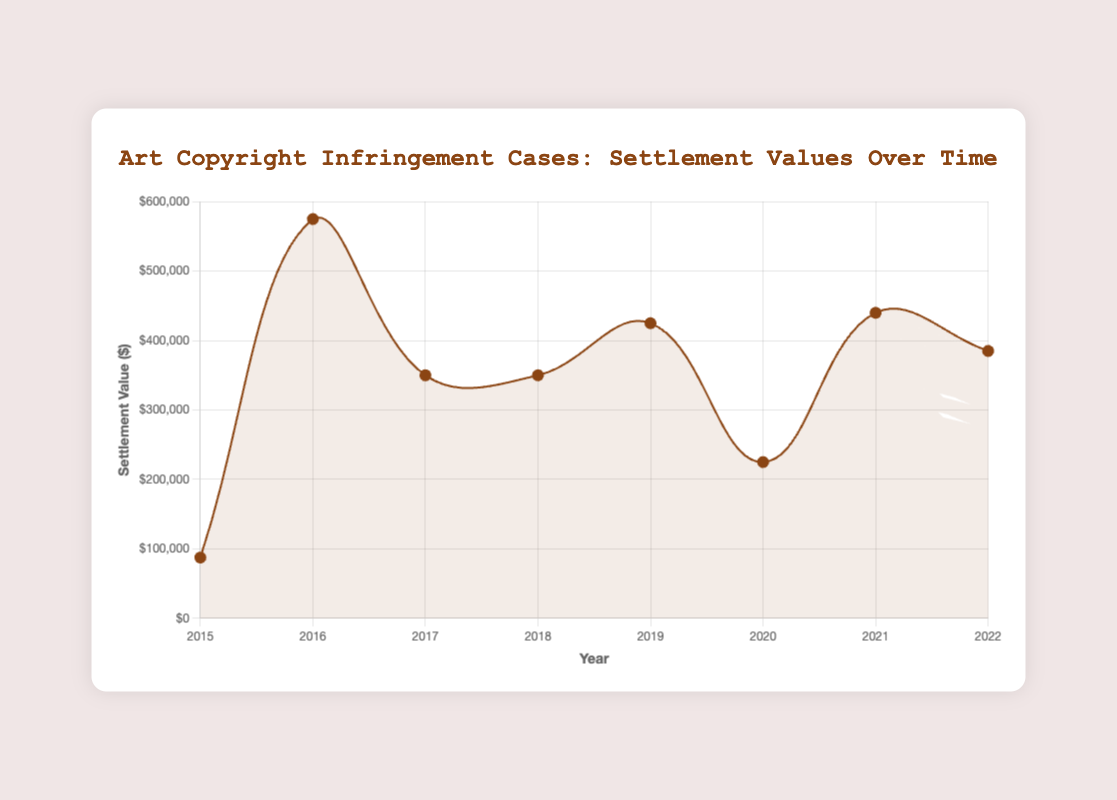What's the highest average settlement value year? The average settlement value can be seen peaking in 2016. Observe that 2016 has the highest data point.
Answer: 2016 Between 2017 and 2019, which year had the lowest average settlement value? Comparing the data points from 2017 to 2019, it's evident that 2017 has the lowest average.
Answer: 2017 How does the average settlement value in 2022 compare to 2020? Visually compare the heights of the points for 2022 and 2020. The point for 2022 is higher than that for 2020.
Answer: 2022 is higher Which years had an average settlement value higher than $500,000? Visually inspect each year's data point and identify those higher than the $500,000 mark. Only 2016 and 2021 appear above this threshold.
Answer: 2016, 2021 What is the trend observed from 2015 to 2022 in average settlement values? The trend seems to fluctuate, with notable peaks in 2016 and 2021, but no clear continuous upward or downward trend.
Answer: Fluctuating How does the average settlement value in 2015 compare to 2018? Compare the heights of the points for 2015 and 2018. The point for 2018 is higher than that for 2015.
Answer: 2018 is higher Which artist had the highest settlement value in any given year, and in what year was it? The highest settlement value observed is $1,000,000 by Jeff Koons in 2016.
Answer: Jeff Koons in 2016 What was the difference in average settlement values between 2021 and 2017? Subtract the average settlement value of 2017 from the average settlement value of 2021. The difference (700000 + 180000)/2 - (300000 + 400000)/2 = 440000 - 350000 = 90000.
Answer: $90,000 What is the average settlement value for 2018? Average the settlement values for the cases in 2018. (500000 + 200000)/2 = 350000.
Answer: $350,000 